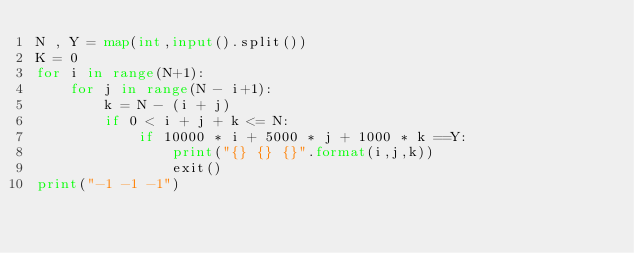<code> <loc_0><loc_0><loc_500><loc_500><_Python_>N , Y = map(int,input().split())
K = 0
for i in range(N+1):
    for j in range(N - i+1):
        k = N - (i + j)
        if 0 < i + j + k <= N:
            if 10000 * i + 5000 * j + 1000 * k ==Y:
                print("{} {} {}".format(i,j,k))
                exit()
print("-1 -1 -1")
</code> 